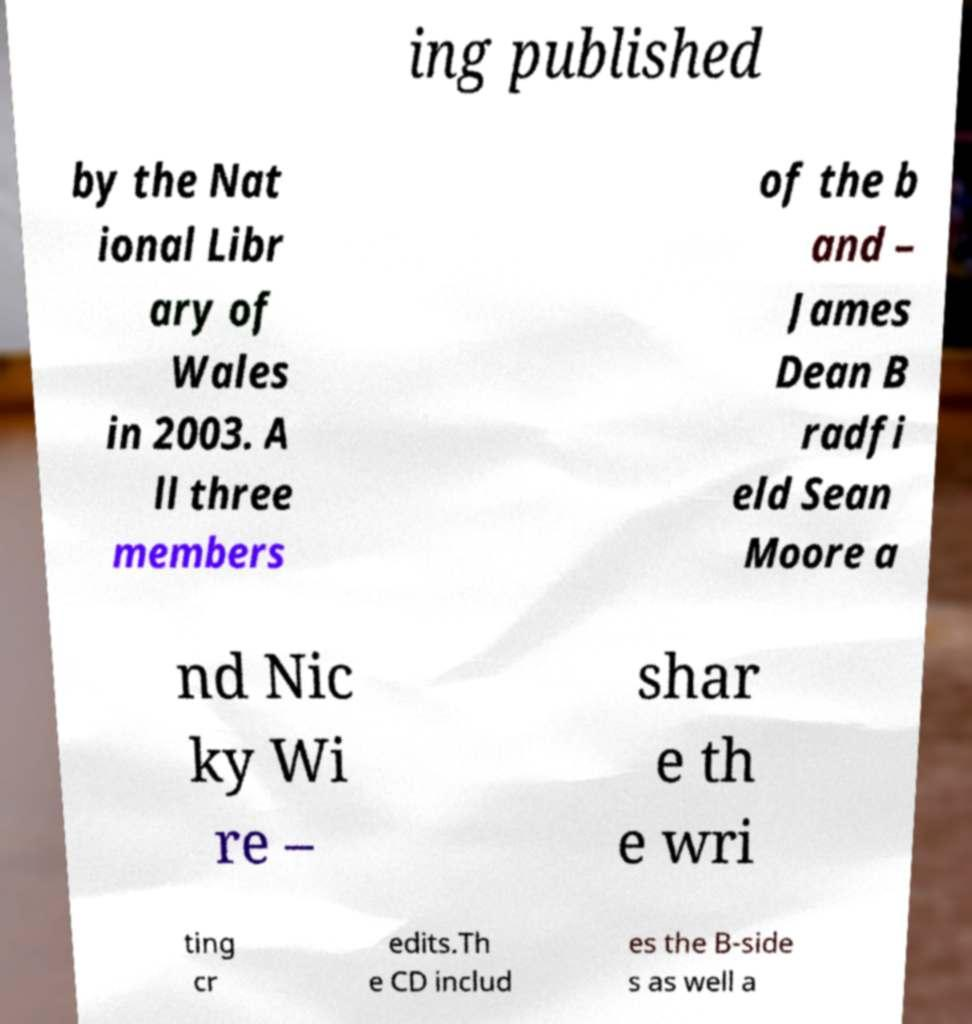Please identify and transcribe the text found in this image. ing published by the Nat ional Libr ary of Wales in 2003. A ll three members of the b and – James Dean B radfi eld Sean Moore a nd Nic ky Wi re – shar e th e wri ting cr edits.Th e CD includ es the B-side s as well a 